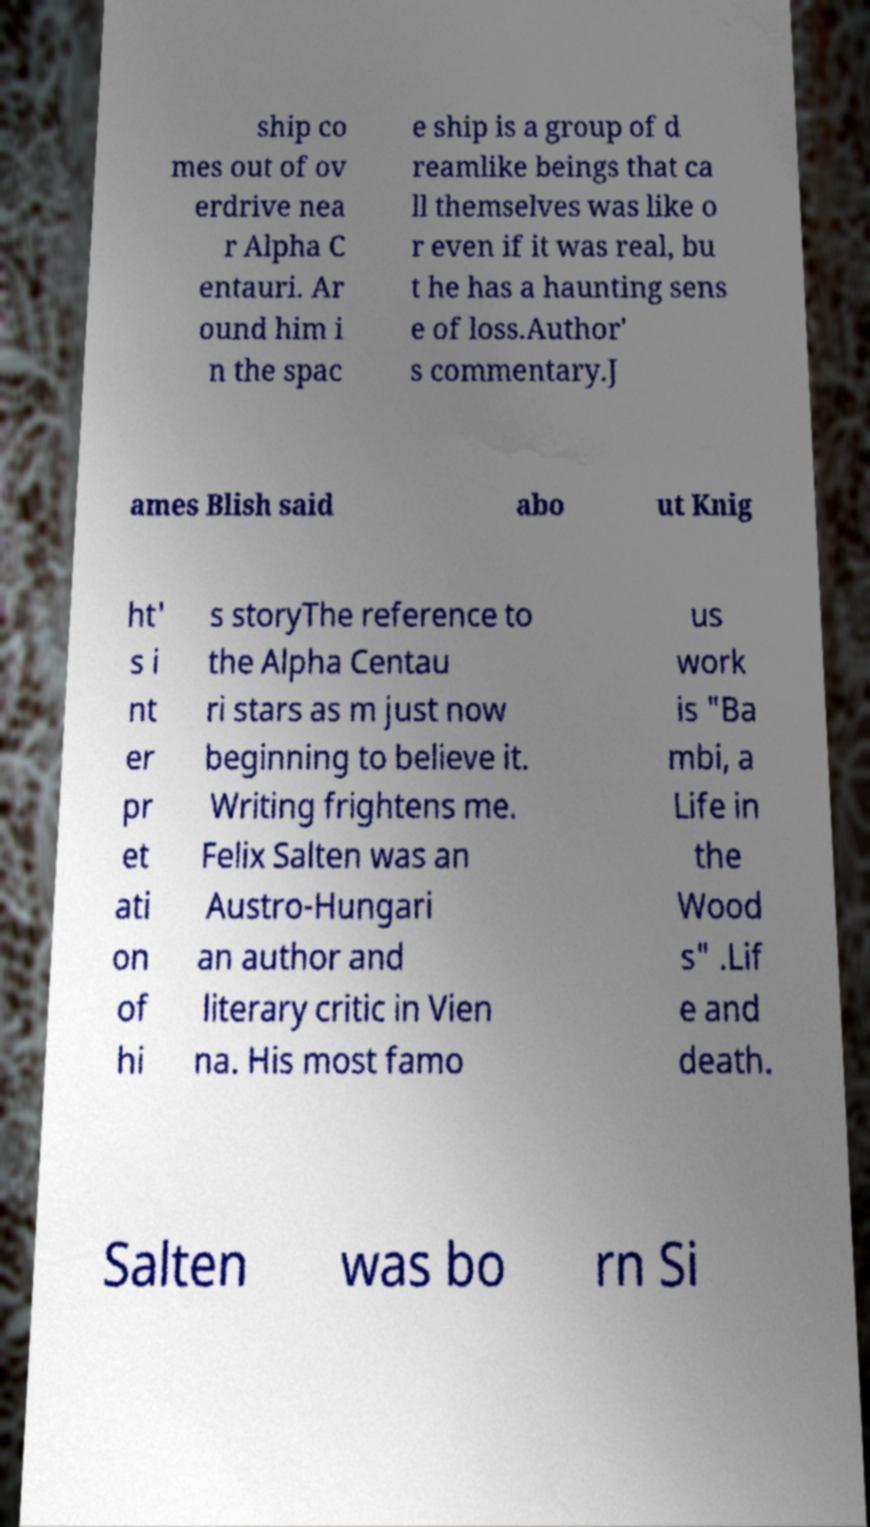Please identify and transcribe the text found in this image. ship co mes out of ov erdrive nea r Alpha C entauri. Ar ound him i n the spac e ship is a group of d reamlike beings that ca ll themselves was like o r even if it was real, bu t he has a haunting sens e of loss.Author' s commentary.J ames Blish said abo ut Knig ht' s i nt er pr et ati on of hi s storyThe reference to the Alpha Centau ri stars as m just now beginning to believe it. Writing frightens me. Felix Salten was an Austro-Hungari an author and literary critic in Vien na. His most famo us work is "Ba mbi, a Life in the Wood s" .Lif e and death. Salten was bo rn Si 